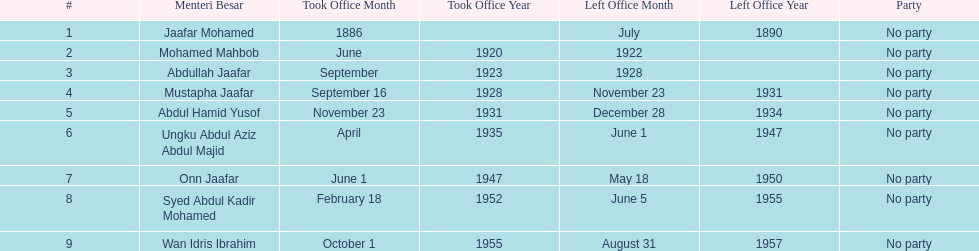What are all the people that were menteri besar of johor? Jaafar Mohamed, Mohamed Mahbob, Abdullah Jaafar, Mustapha Jaafar, Abdul Hamid Yusof, Ungku Abdul Aziz Abdul Majid, Onn Jaafar, Syed Abdul Kadir Mohamed, Wan Idris Ibrahim. Who ruled the longest? Ungku Abdul Aziz Abdul Majid. 